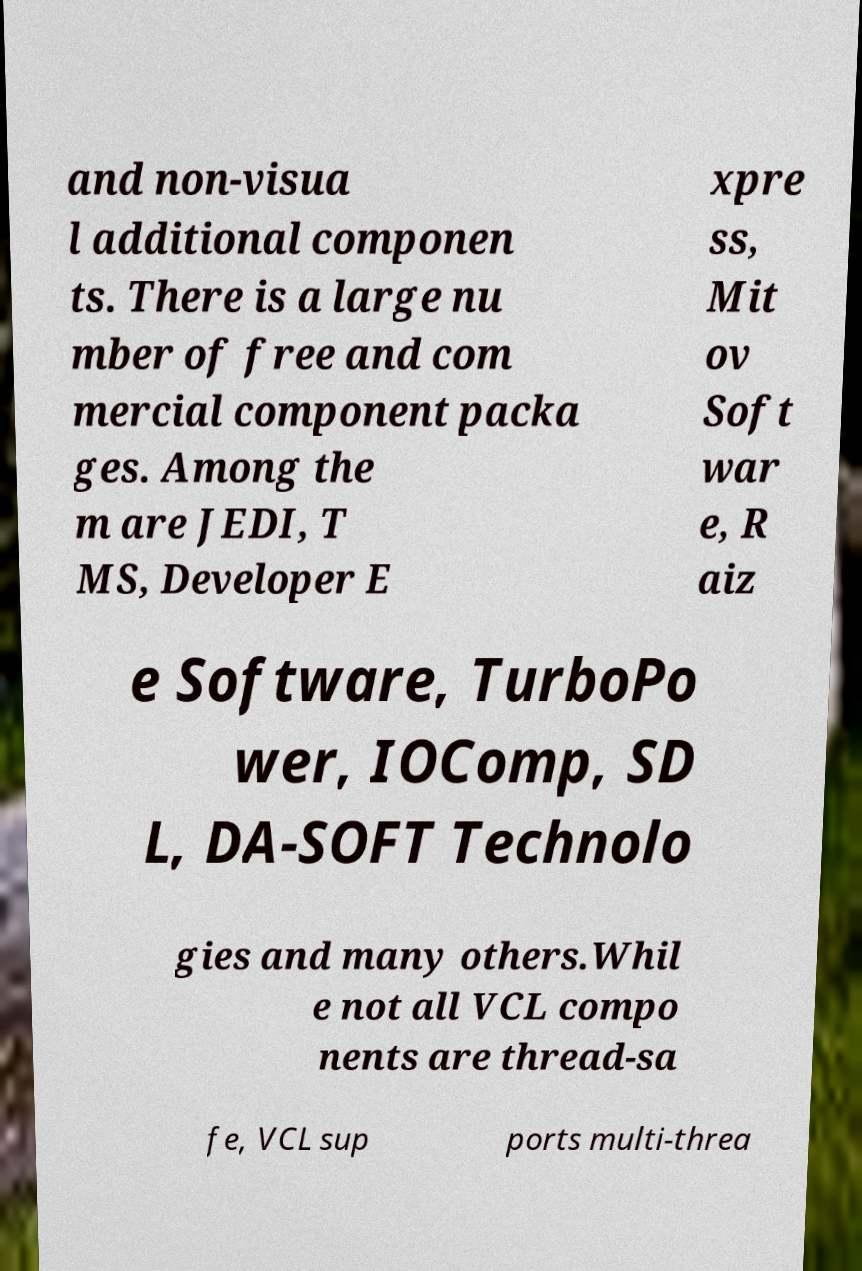Could you assist in decoding the text presented in this image and type it out clearly? and non-visua l additional componen ts. There is a large nu mber of free and com mercial component packa ges. Among the m are JEDI, T MS, Developer E xpre ss, Mit ov Soft war e, R aiz e Software, TurboPo wer, IOComp, SD L, DA-SOFT Technolo gies and many others.Whil e not all VCL compo nents are thread-sa fe, VCL sup ports multi-threa 